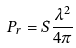Convert formula to latex. <formula><loc_0><loc_0><loc_500><loc_500>P _ { r } = S \frac { \lambda ^ { 2 } } { 4 \pi }</formula> 